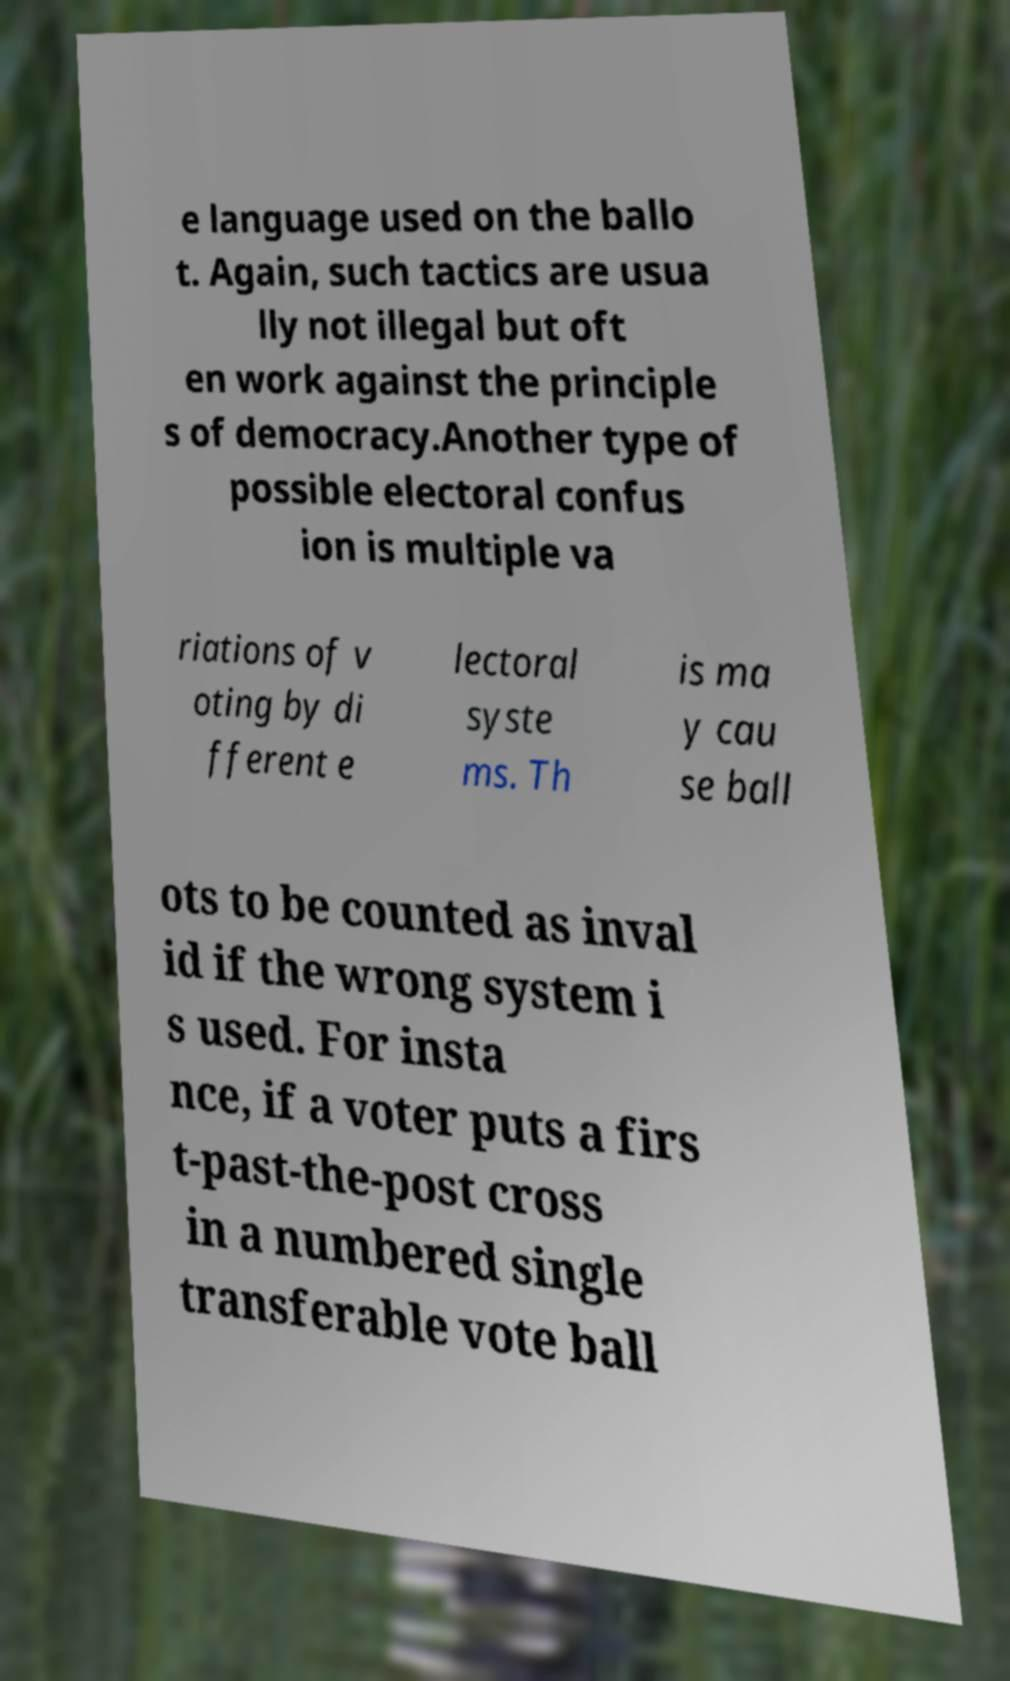I need the written content from this picture converted into text. Can you do that? e language used on the ballo t. Again, such tactics are usua lly not illegal but oft en work against the principle s of democracy.Another type of possible electoral confus ion is multiple va riations of v oting by di fferent e lectoral syste ms. Th is ma y cau se ball ots to be counted as inval id if the wrong system i s used. For insta nce, if a voter puts a firs t-past-the-post cross in a numbered single transferable vote ball 